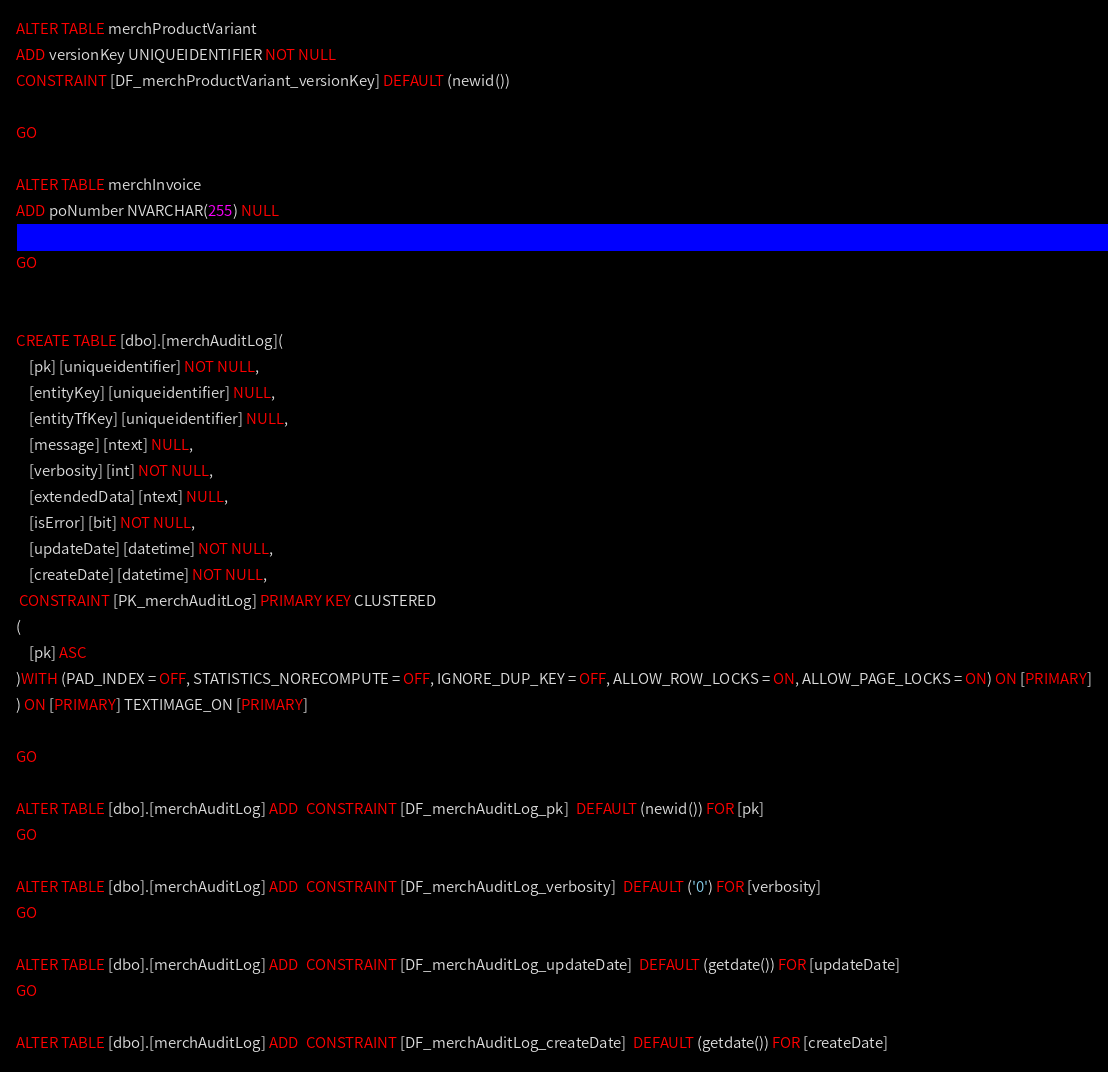Convert code to text. <code><loc_0><loc_0><loc_500><loc_500><_SQL_>ALTER TABLE merchProductVariant
ADD versionKey UNIQUEIDENTIFIER NOT NULL
CONSTRAINT [DF_merchProductVariant_versionKey] DEFAULT (newid())

GO

ALTER TABLE merchInvoice
ADD poNumber NVARCHAR(255) NULL

GO


CREATE TABLE [dbo].[merchAuditLog](
	[pk] [uniqueidentifier] NOT NULL,
	[entityKey] [uniqueidentifier] NULL,
	[entityTfKey] [uniqueidentifier] NULL,
	[message] [ntext] NULL,
	[verbosity] [int] NOT NULL,
	[extendedData] [ntext] NULL,
	[isError] [bit] NOT NULL,
	[updateDate] [datetime] NOT NULL,
	[createDate] [datetime] NOT NULL,
 CONSTRAINT [PK_merchAuditLog] PRIMARY KEY CLUSTERED 
(
	[pk] ASC
)WITH (PAD_INDEX = OFF, STATISTICS_NORECOMPUTE = OFF, IGNORE_DUP_KEY = OFF, ALLOW_ROW_LOCKS = ON, ALLOW_PAGE_LOCKS = ON) ON [PRIMARY]
) ON [PRIMARY] TEXTIMAGE_ON [PRIMARY]

GO

ALTER TABLE [dbo].[merchAuditLog] ADD  CONSTRAINT [DF_merchAuditLog_pk]  DEFAULT (newid()) FOR [pk]
GO

ALTER TABLE [dbo].[merchAuditLog] ADD  CONSTRAINT [DF_merchAuditLog_verbosity]  DEFAULT ('0') FOR [verbosity]
GO

ALTER TABLE [dbo].[merchAuditLog] ADD  CONSTRAINT [DF_merchAuditLog_updateDate]  DEFAULT (getdate()) FOR [updateDate]
GO

ALTER TABLE [dbo].[merchAuditLog] ADD  CONSTRAINT [DF_merchAuditLog_createDate]  DEFAULT (getdate()) FOR [createDate]
</code> 